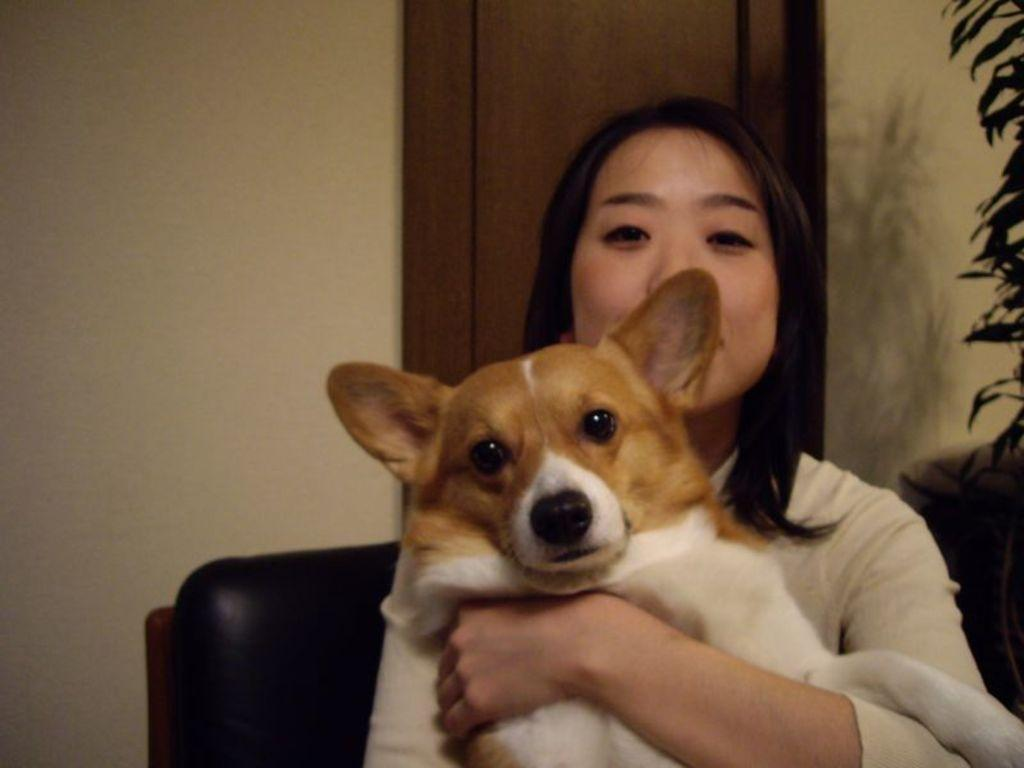What is the person in the image doing? The person is sitting on a chair. What is the person holding in the image? The person is holding a dog. What can be seen in the background of the image? There is a wall in the background of the image. What type of insurance does the person have for the dog in the image? There is no information about insurance for the dog in the image. 